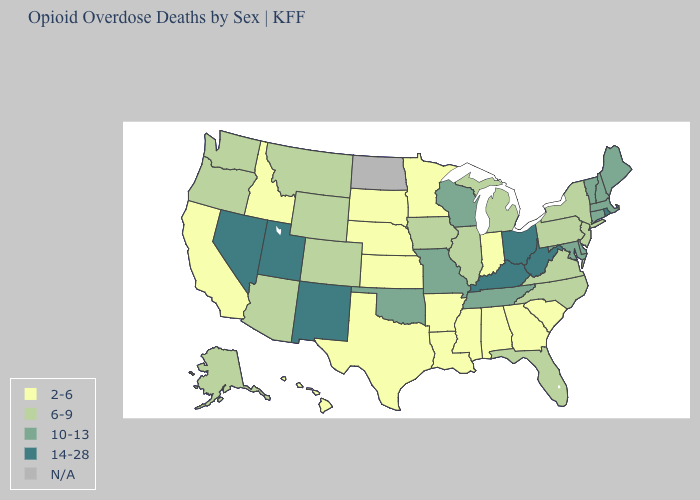Name the states that have a value in the range 14-28?
Be succinct. Kentucky, Nevada, New Mexico, Ohio, Rhode Island, Utah, West Virginia. Among the states that border Idaho , does Nevada have the highest value?
Quick response, please. Yes. Name the states that have a value in the range N/A?
Be succinct. North Dakota. Is the legend a continuous bar?
Give a very brief answer. No. Among the states that border Idaho , does Wyoming have the highest value?
Give a very brief answer. No. Among the states that border Oklahoma , does Kansas have the highest value?
Write a very short answer. No. Which states have the highest value in the USA?
Answer briefly. Kentucky, Nevada, New Mexico, Ohio, Rhode Island, Utah, West Virginia. What is the value of Rhode Island?
Write a very short answer. 14-28. Among the states that border Ohio , which have the lowest value?
Write a very short answer. Indiana. Does New Mexico have the highest value in the West?
Quick response, please. Yes. What is the highest value in the USA?
Concise answer only. 14-28. Name the states that have a value in the range N/A?
Be succinct. North Dakota. Does Kentucky have the highest value in the USA?
Be succinct. Yes. Does Kentucky have the lowest value in the USA?
Concise answer only. No. 